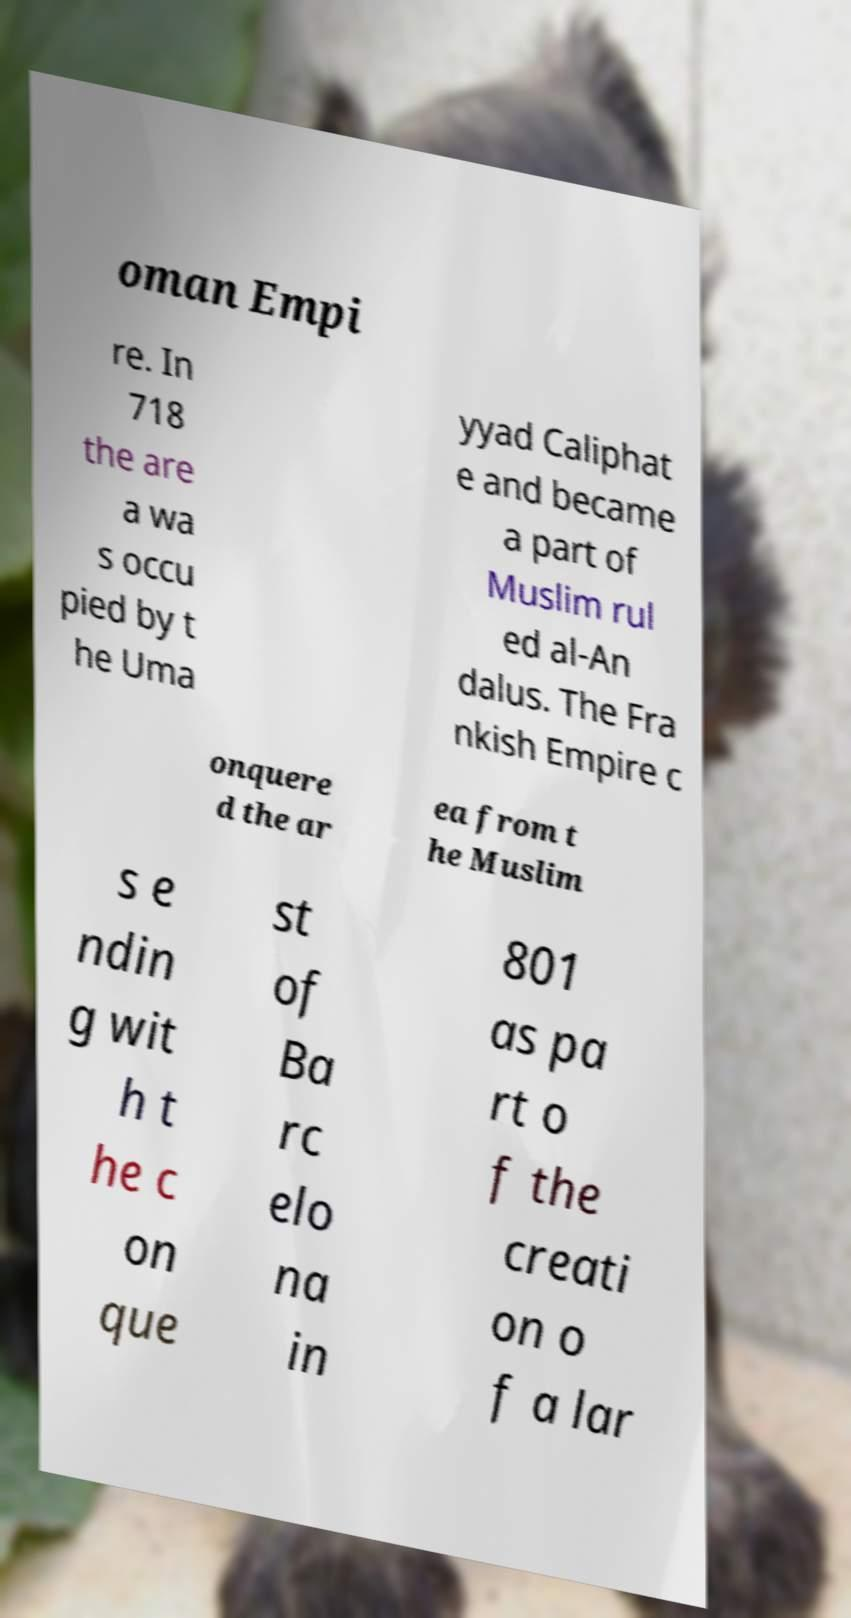Can you accurately transcribe the text from the provided image for me? oman Empi re. In 718 the are a wa s occu pied by t he Uma yyad Caliphat e and became a part of Muslim rul ed al-An dalus. The Fra nkish Empire c onquere d the ar ea from t he Muslim s e ndin g wit h t he c on que st of Ba rc elo na in 801 as pa rt o f the creati on o f a lar 